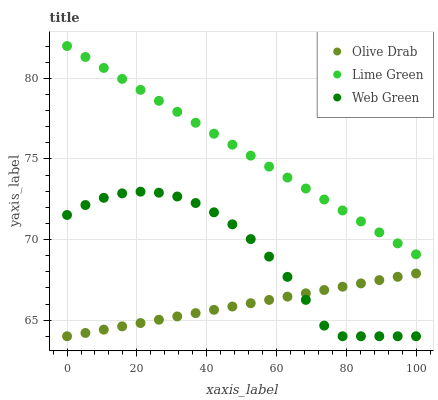Does Olive Drab have the minimum area under the curve?
Answer yes or no. Yes. Does Lime Green have the maximum area under the curve?
Answer yes or no. Yes. Does Web Green have the minimum area under the curve?
Answer yes or no. No. Does Web Green have the maximum area under the curve?
Answer yes or no. No. Is Olive Drab the smoothest?
Answer yes or no. Yes. Is Web Green the roughest?
Answer yes or no. Yes. Is Web Green the smoothest?
Answer yes or no. No. Is Olive Drab the roughest?
Answer yes or no. No. Does Web Green have the lowest value?
Answer yes or no. Yes. Does Lime Green have the highest value?
Answer yes or no. Yes. Does Web Green have the highest value?
Answer yes or no. No. Is Web Green less than Lime Green?
Answer yes or no. Yes. Is Lime Green greater than Olive Drab?
Answer yes or no. Yes. Does Web Green intersect Olive Drab?
Answer yes or no. Yes. Is Web Green less than Olive Drab?
Answer yes or no. No. Is Web Green greater than Olive Drab?
Answer yes or no. No. Does Web Green intersect Lime Green?
Answer yes or no. No. 